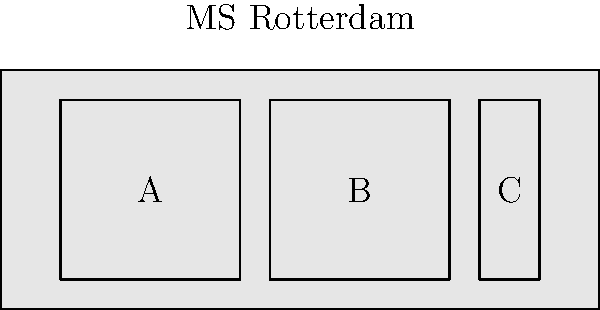The MS Rotterdam, named after the Dutch city, has three cargo holds (A, B, and C) as shown in the diagram. Given that hold A can store 300 tons, hold B can store 400 tons, and hold C can store 100 tons, what is the optimal arrangement of cargo to ensure the ship remains balanced if you need to transport exactly 600 tons? To determine the optimal arrangement of cargo for balancing the ship, we need to follow these steps:

1. Understand the ship's layout:
   - Hold A is on the left (bow)
   - Hold B is in the middle
   - Hold C is on the right (stern)

2. Consider the capacity of each hold:
   - Hold A: 300 tons
   - Hold B: 400 tons
   - Hold C: 100 tons

3. Calculate the total required cargo: 600 tons

4. To balance the ship, we need to distribute the weight evenly across the length of the vessel. The ideal distribution would be to place more weight in the middle (Hold B) and equal weights on both ends.

5. We can achieve this by:
   - Filling Hold B to capacity: 400 tons
   - Distributing the remaining 200 tons equally between Hold A and Hold C

6. The optimal arrangement:
   - Hold A: 100 tons
   - Hold B: 400 tons
   - Hold C: 100 tons

This arrangement ensures that:
- The total cargo is 600 tons (100 + 400 + 100 = 600)
- The weight is centered in the middle of the ship (Hold B)
- The remaining weight is equally distributed between the bow and stern (Holds A and C)
Answer: A: 100 tons, B: 400 tons, C: 100 tons 